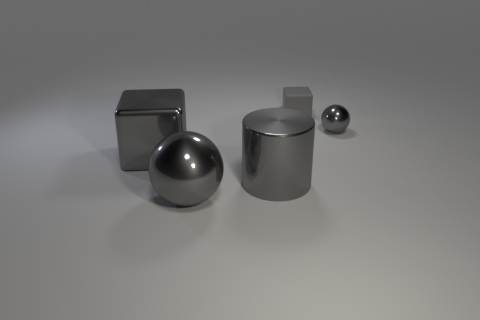Add 2 large blue rubber balls. How many objects exist? 7 Subtract all cylinders. How many objects are left? 4 Subtract all cyan cylinders. Subtract all blue cubes. How many cylinders are left? 1 Subtract all big gray shiny cylinders. Subtract all tiny matte blocks. How many objects are left? 3 Add 3 gray shiny cylinders. How many gray shiny cylinders are left? 4 Add 3 red shiny cylinders. How many red shiny cylinders exist? 3 Subtract 0 cyan cylinders. How many objects are left? 5 